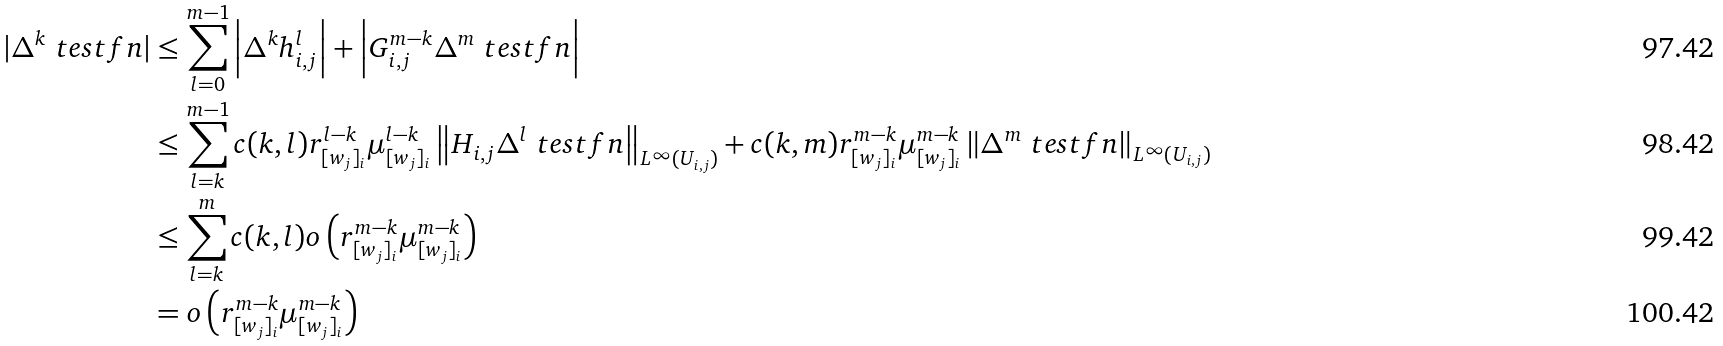<formula> <loc_0><loc_0><loc_500><loc_500>| \Delta ^ { k } \ t e s t f n | & \leq \sum _ { l = 0 } ^ { m - 1 } \left | \Delta ^ { k } h _ { i , j } ^ { l } \right | + \left | G _ { i , j } ^ { m - k } \Delta ^ { m } \ t e s t f n \right | \\ & \leq \sum _ { l = k } ^ { m - 1 } c ( k , l ) r _ { [ w _ { j } ] _ { i } } ^ { l - k } \mu _ { [ w _ { j } ] _ { i } } ^ { l - k } \left \| H _ { i , j } \Delta ^ { l } \ t e s t f n \right \| _ { L ^ { \infty } ( U _ { i , j } ) } + c ( k , m ) r _ { [ w _ { j } ] _ { i } } ^ { m - k } \mu _ { [ w _ { j } ] _ { i } } ^ { m - k } \left \| \Delta ^ { m } \ t e s t f n \right \| _ { L ^ { \infty } ( U _ { i , j } ) } \\ & \leq \sum _ { l = k } ^ { m } c ( k , l ) o \left ( r _ { [ w _ { j } ] _ { i } } ^ { m - k } \mu _ { [ w _ { j } ] _ { i } } ^ { m - k } \right ) \\ & = o \left ( r _ { [ w _ { j } ] _ { i } } ^ { m - k } \mu _ { [ w _ { j } ] _ { i } } ^ { m - k } \right )</formula> 